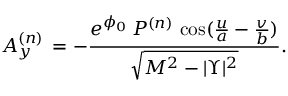Convert formula to latex. <formula><loc_0><loc_0><loc_500><loc_500>A _ { y } ^ { ( n ) } \, = - { \frac { { e ^ { \phi _ { 0 } } } \, P ^ { ( n ) } \, \cos ( { \frac { u } { a } } - { \frac { v } { b } } ) } { { \sqrt { { M ^ { 2 } } - { | \Upsilon | ^ { 2 } } } } } } .</formula> 